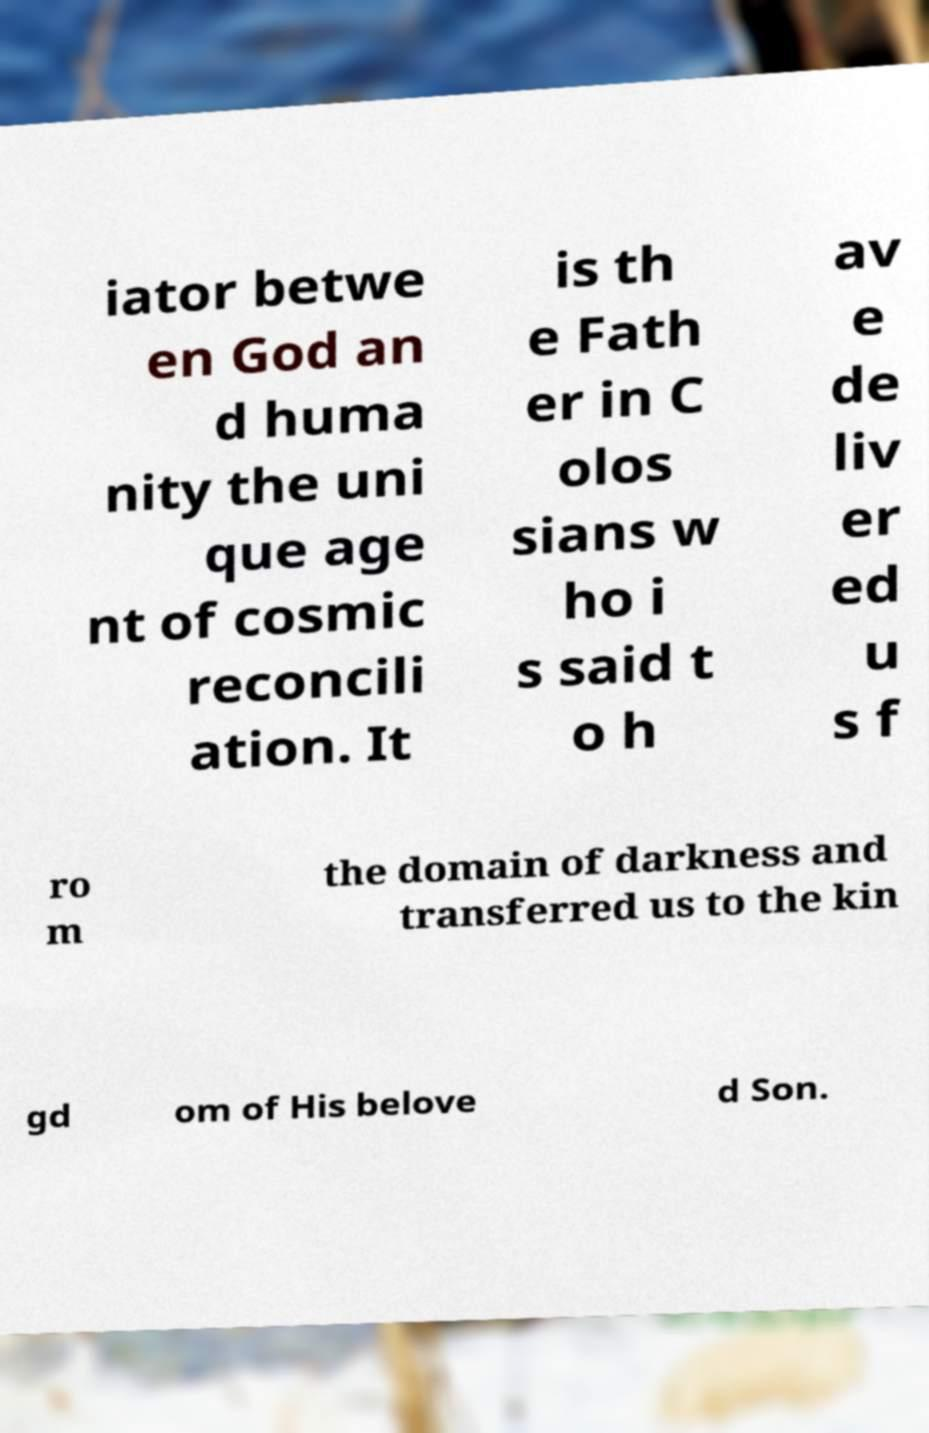Can you accurately transcribe the text from the provided image for me? iator betwe en God an d huma nity the uni que age nt of cosmic reconcili ation. It is th e Fath er in C olos sians w ho i s said t o h av e de liv er ed u s f ro m the domain of darkness and transferred us to the kin gd om of His belove d Son. 